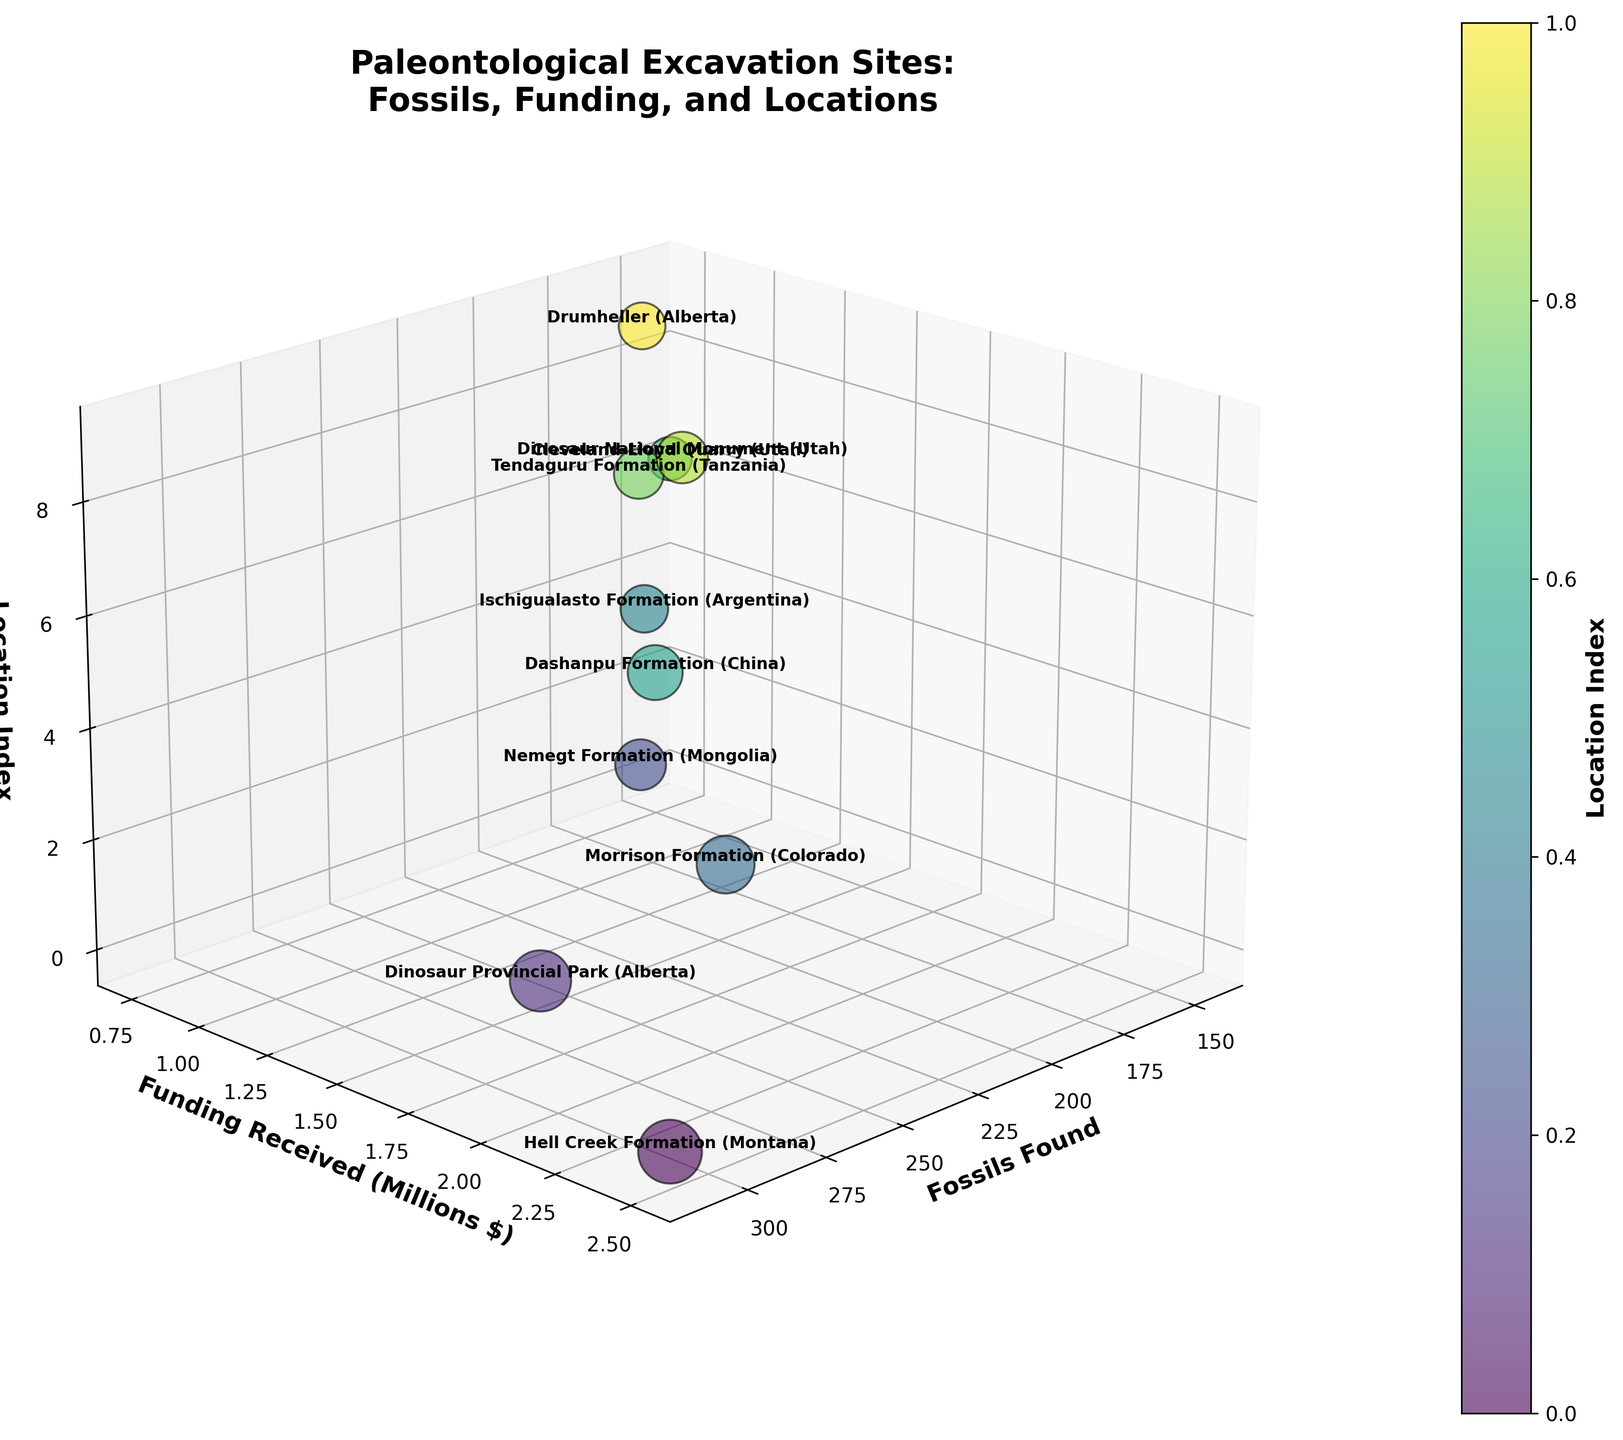What do the axes represent? The x-axis represents the number of fossils found at each location. The y-axis shows the funding received (in millions of dollars). The z-axis represents the location index.
Answer: Number of fossils, Funding received, Location index How many paleontological excavation sites are represented in the plot? The number of data points or locations can be determined by counting the unique points in the z-axis, which represent the location indices.
Answer: 10 Which location received the highest funding and how much was it? Identify the tallest bubble or the one that extends the furthest on the y-axis. The label near this bubble will indicate the location. In this case, it appears to be "Hell Creek Formation (Montana)" with 2500000 or 2.5 million dollars in funding.
Answer: Hell Creek Formation (Montana), 2.5 million Is there a relationship between the number of fossils found and the amount of funding received? By observing the trend in the scatter plot, we can see if there is a pattern where higher numbers of fossils found are associated with more funding received. Generally, it appears that sites with more fossils received higher funding.
Answer: Positive correlation Which location had the fewest fossils found, and how many were found there? Look for the smallest bubble or the data point with the lowest value on the x-axis. The corresponding label provides the location. "Cleveland-Lloyd Quarry (Utah)" has the fewest fossils at 145.
Answer: Cleveland-Lloyd Quarry (Utah), 145 Which site is represented by the largest bubble size and what does it indicate? The bubble size is proportional to the number of fossils found. The largest bubble represents "Hell Creek Formation (Montana)", indicating it had the highest number of fossils found at 312.
Answer: Hell Creek Formation (Montana), indicates 312 fossils Compare the funding received by Dinosaur Provincial Park (Alberta) and Ischigualasto Formation (Argentina). Locate both on the plot and compare their positions on the y-axis. Dinosaur Provincial Park (Alberta) has funding of 1800000 or 1.8 million, and Ischigualasto Formation (Argentina) has 950000 or 0.95 million. Dinosaur Provincial Park received more funding.
Answer: Dinosaur Provincial Park (Alberta) received more What is the average funding received across all locations? Sum all the funding received and divide by the number of locations. (2500000+1800000+1200000+2100000+950000+1600000+750000+1100000+1400000+880000) / 10 = 13750000 / 10 = 1375000 or 1.375 million dollars.
Answer: 1.375 million dollars Which location is the second highest on the y-axis, and what is the amount? The second-highest point on the y-axis after Hell Creek Formation (Montana) is identified and labeled. It is "Morrison Formation (Colorado)" with funding of 2100000 or 2.1 million dollars.
Answer: Morrison Formation (Colorado), 2.1 million Which location is located at index 5 on the z-axis? The z-axis represents the location index. Count from 0 to 5 along the z-axis to identify the fifth location. The label indicates it is "Dashanpu Formation (China)".
Answer: Dashanpu Formation (China) 